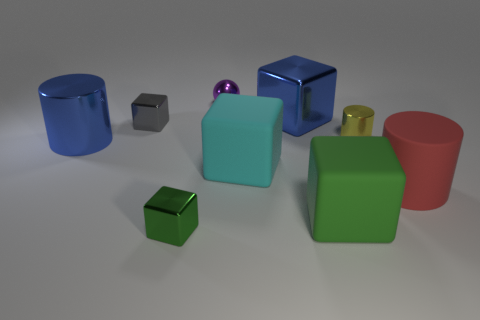What time of day does the lighting in this scene suggest? The lighting in the scene doesn't strongly suggest a particular time of day as it appears to be a neutral, artificial light commonly used in indoor photography or 3D renderings without a specific daylight effect. 